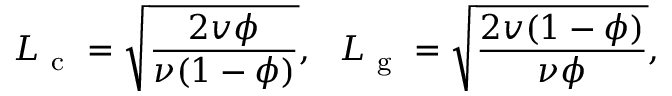Convert formula to latex. <formula><loc_0><loc_0><loc_500><loc_500>L _ { c } = \sqrt { \frac { 2 v \phi } { \nu ( 1 - \phi ) } } , \, L _ { g } = \sqrt { \frac { 2 v ( 1 - \phi ) } { \nu \phi } } ,</formula> 